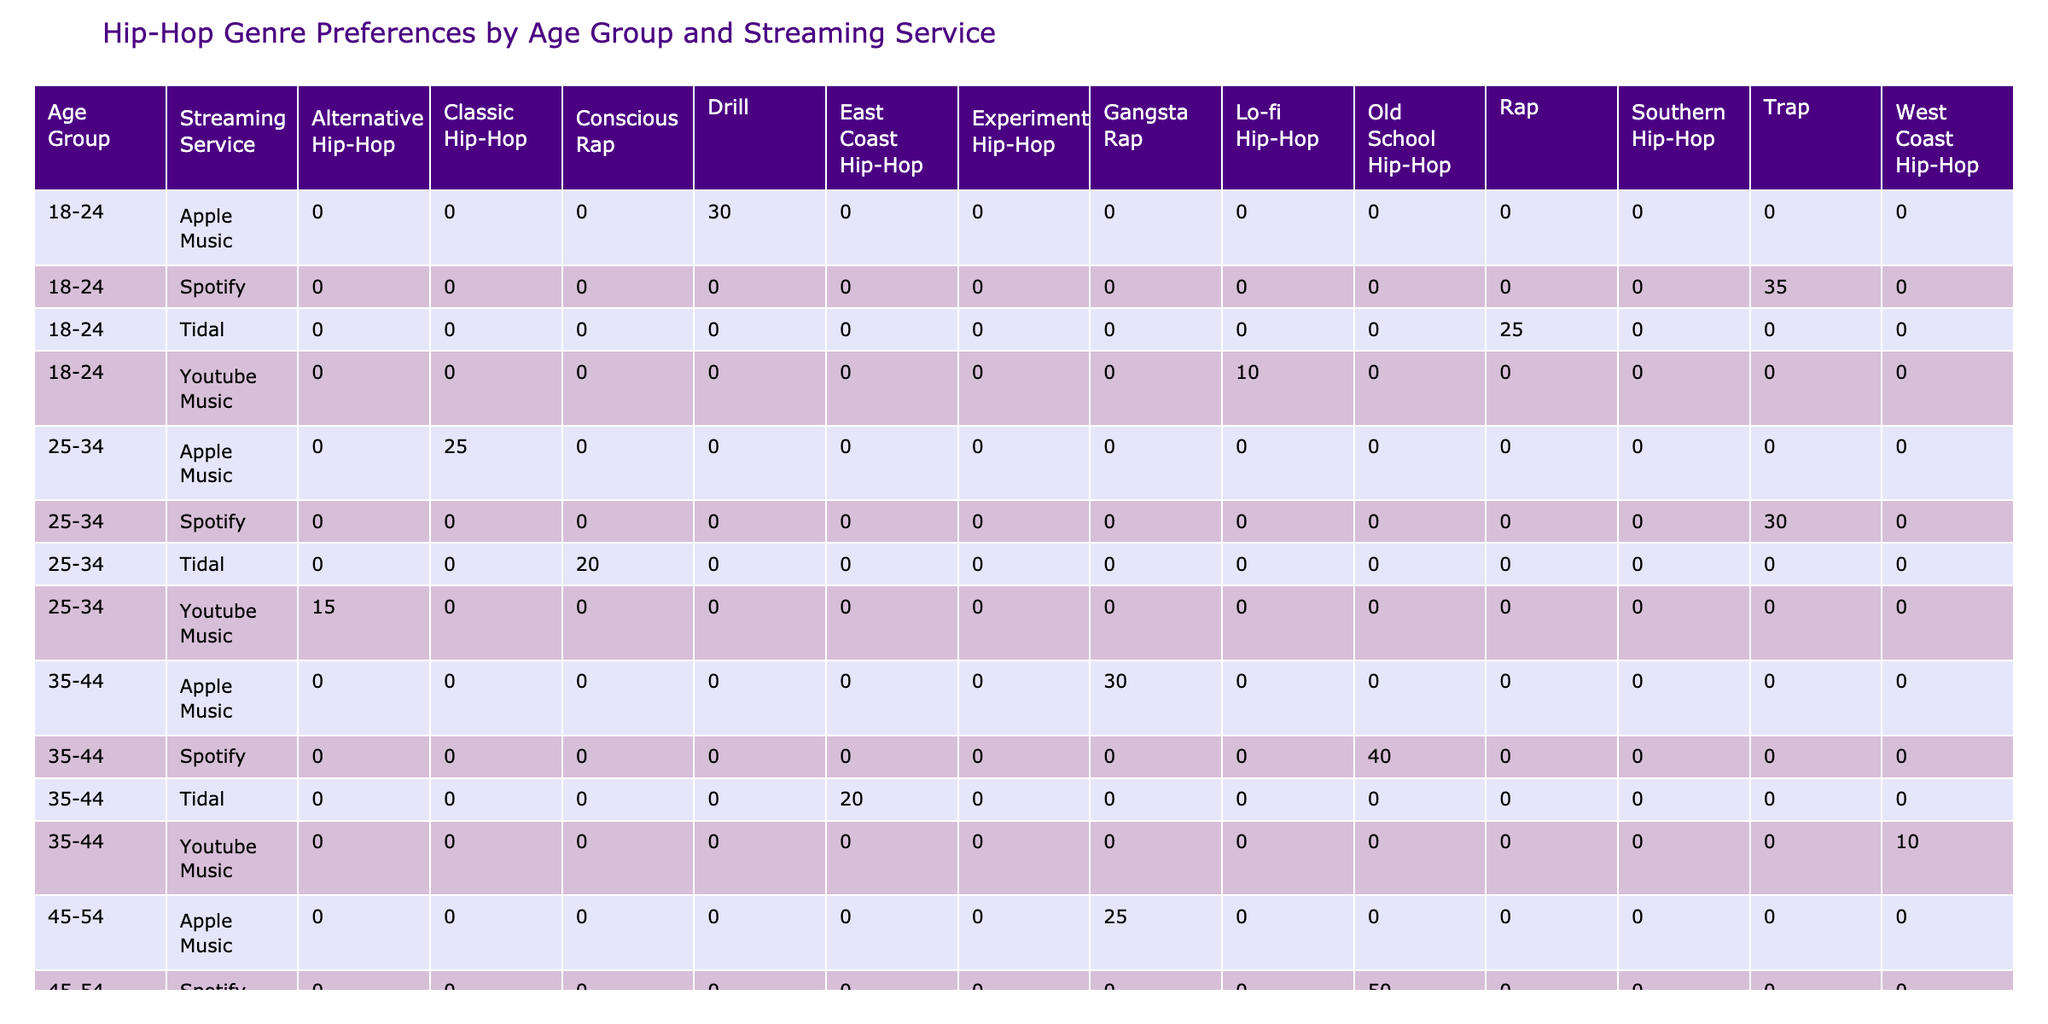What is the percentage of 18-24 year-olds using Spotify for Trap music? The data shows that 35% of the 18-24 age group prefers Trap music on Spotify. This can be found directly in the relevant row of the table.
Answer: 35% Which streaming service do 25-34 year-olds prefer for Classic Hip-Hop? According to the table, 25% of 25-34 year-olds use Apple Music for Classic Hip-Hop, as indicated in the respective row under the corresponding age group and service.
Answer: Apple Music For the 45-54 age group, what is the total percentage of listeners across all streaming services for Gangsta Rap? Adding the percentages, we see that 25% listen to Gangsta Rap on Apple Music and 0% on the other services (as they don't have this genre listed for this age group). Therefore, the total percentage is 25%.
Answer: 25% Is Tidal the preferred streaming service for any age group for Drill music? Looking through the table, we find that Tidal does not appear for any age group with Drill music. As such, the answer is No.
Answer: No What is the difference in percentage preference for Old School Hip-Hop on Spotify between the 35-44 and 45-54 age groups? The percentage for the 35-44 age group is 40% while for the 45-54 age group it is 50%. The difference is calculated as 50% - 40% = 10%.
Answer: 10% Which streaming service sees the highest percentage preference for Rap music in the 18-24 age group? In the 18-24 age group, Tidal has a preference of 25% for Rap, which is higher than the other services listed for that genre. The row clearly indicates this preference.
Answer: Tidal Are there any genres that are preferred more than 30% on YouTube Music for any age group? In the table, the maximum percentage recorded for YouTube Music across any age group is 15% for Alternative Hip-Hop (25-34 age group). Hence, the answer is No.
Answer: No How does the percentage of Trap music listeners on Spotify compare to Drill music listeners on Apple Music for the 18-24 age group? The percentage for Trap music listeners on Spotify is 35%, while listeners for Drill music on Apple Music is 30%. Comparing these values, 35% (Trap) is greater than 30% (Drill) by 5%.
Answer: 5% What genre has the lowest preference among 35-44 year-olds on YouTube Music? For age group 35-44, the lowest percentage indicated on YouTube Music is 10% for West Coast Hip-Hop. This can be directly referenced in the table under the given age group and service.
Answer: West Coast Hip-Hop 